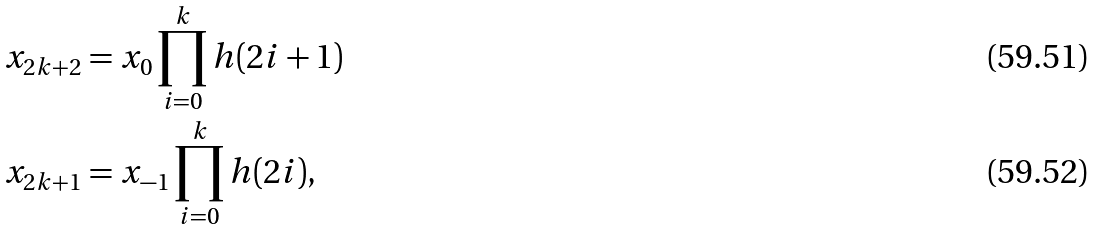Convert formula to latex. <formula><loc_0><loc_0><loc_500><loc_500>x _ { 2 k + 2 } & = x _ { 0 } \prod _ { i = 0 } ^ { k } h ( 2 i + 1 ) \\ x _ { 2 k + 1 } & = x _ { - 1 } \prod _ { i = 0 } ^ { k } h ( 2 i ) ,</formula> 